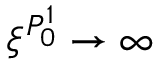<formula> <loc_0><loc_0><loc_500><loc_500>\xi ^ { P _ { 0 } ^ { 1 } } \to \infty</formula> 